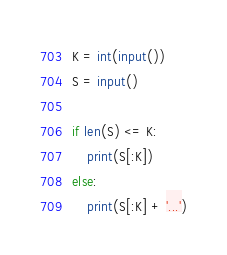Convert code to text. <code><loc_0><loc_0><loc_500><loc_500><_Python_>K = int(input())
S = input()

if len(S) <= K:
    print(S[:K])
else:
    print(S[:K] + '...')</code> 